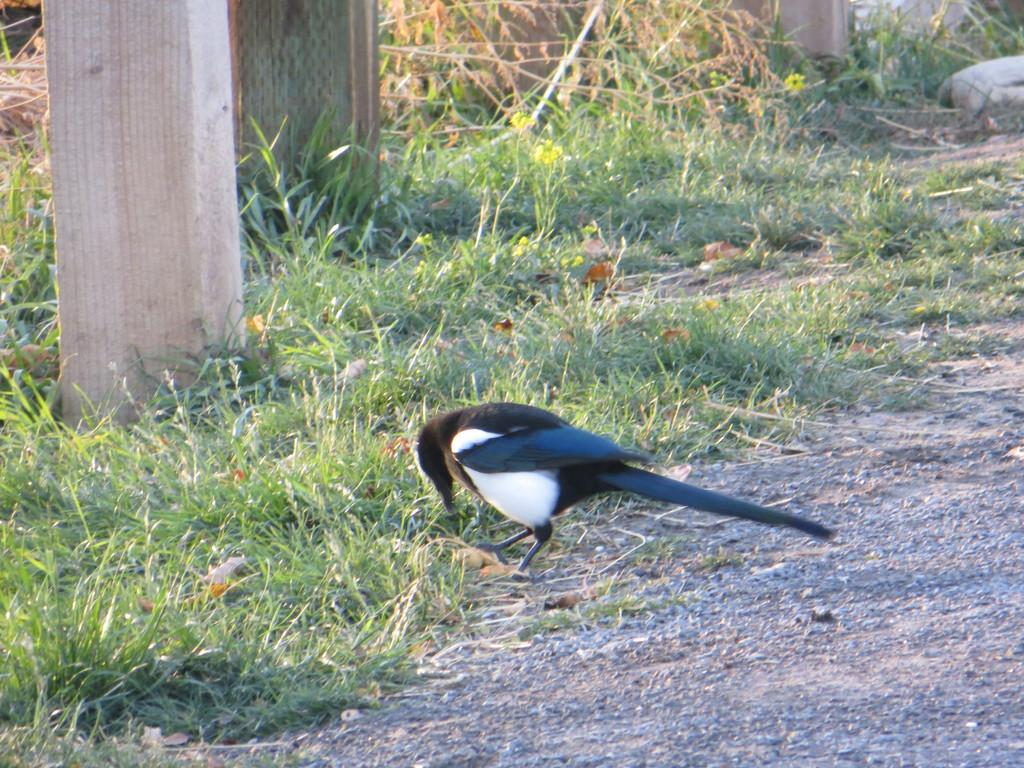What is the main subject in the center of the image? There is a bird in the center of the image. Where is the bird located? The bird is on the ground. What type of vegetation covers the ground? The ground is covered with grass. What can be seen in the background of the image? There are pillars and rocks in the background of the image. How does the bird increase its speed while flying in the image? The bird is not flying in the image; it is on the ground. What type of nut is the bird holding in its beak in the image? There is no nut present in the image; the bird is simply standing on the ground. 